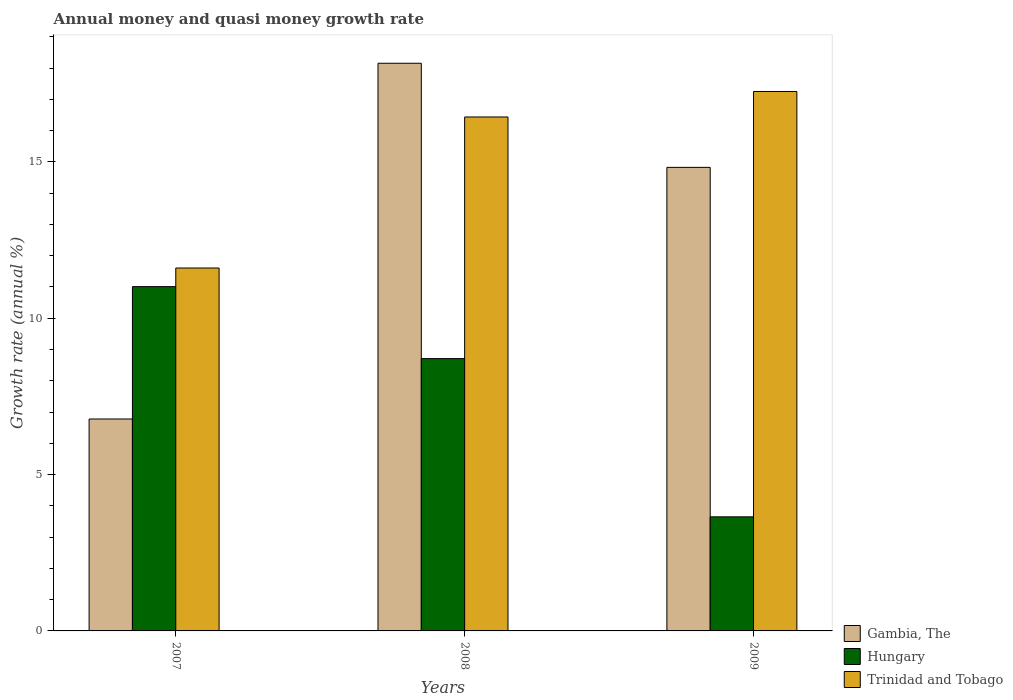How many different coloured bars are there?
Offer a very short reply. 3. Are the number of bars per tick equal to the number of legend labels?
Provide a succinct answer. Yes. How many bars are there on the 3rd tick from the right?
Keep it short and to the point. 3. In how many cases, is the number of bars for a given year not equal to the number of legend labels?
Provide a short and direct response. 0. What is the growth rate in Gambia, The in 2009?
Provide a succinct answer. 14.83. Across all years, what is the maximum growth rate in Gambia, The?
Offer a terse response. 18.16. Across all years, what is the minimum growth rate in Hungary?
Offer a very short reply. 3.65. In which year was the growth rate in Trinidad and Tobago minimum?
Provide a succinct answer. 2007. What is the total growth rate in Hungary in the graph?
Give a very brief answer. 23.37. What is the difference between the growth rate in Trinidad and Tobago in 2007 and that in 2009?
Keep it short and to the point. -5.65. What is the difference between the growth rate in Trinidad and Tobago in 2008 and the growth rate in Hungary in 2009?
Give a very brief answer. 12.79. What is the average growth rate in Trinidad and Tobago per year?
Keep it short and to the point. 15.1. In the year 2009, what is the difference between the growth rate in Trinidad and Tobago and growth rate in Gambia, The?
Provide a succinct answer. 2.43. What is the ratio of the growth rate in Trinidad and Tobago in 2007 to that in 2008?
Offer a terse response. 0.71. What is the difference between the highest and the second highest growth rate in Trinidad and Tobago?
Offer a terse response. 0.82. What is the difference between the highest and the lowest growth rate in Gambia, The?
Provide a succinct answer. 11.38. In how many years, is the growth rate in Trinidad and Tobago greater than the average growth rate in Trinidad and Tobago taken over all years?
Provide a short and direct response. 2. What does the 3rd bar from the left in 2008 represents?
Your answer should be very brief. Trinidad and Tobago. What does the 3rd bar from the right in 2009 represents?
Ensure brevity in your answer.  Gambia, The. Is it the case that in every year, the sum of the growth rate in Trinidad and Tobago and growth rate in Gambia, The is greater than the growth rate in Hungary?
Keep it short and to the point. Yes. Are all the bars in the graph horizontal?
Offer a very short reply. No. How many years are there in the graph?
Offer a very short reply. 3. What is the difference between two consecutive major ticks on the Y-axis?
Provide a succinct answer. 5. Are the values on the major ticks of Y-axis written in scientific E-notation?
Keep it short and to the point. No. Where does the legend appear in the graph?
Provide a short and direct response. Bottom right. How many legend labels are there?
Give a very brief answer. 3. What is the title of the graph?
Your answer should be compact. Annual money and quasi money growth rate. What is the label or title of the Y-axis?
Your response must be concise. Growth rate (annual %). What is the Growth rate (annual %) in Gambia, The in 2007?
Give a very brief answer. 6.78. What is the Growth rate (annual %) in Hungary in 2007?
Provide a short and direct response. 11.01. What is the Growth rate (annual %) in Trinidad and Tobago in 2007?
Ensure brevity in your answer.  11.61. What is the Growth rate (annual %) in Gambia, The in 2008?
Ensure brevity in your answer.  18.16. What is the Growth rate (annual %) in Hungary in 2008?
Provide a short and direct response. 8.71. What is the Growth rate (annual %) in Trinidad and Tobago in 2008?
Provide a succinct answer. 16.44. What is the Growth rate (annual %) in Gambia, The in 2009?
Offer a very short reply. 14.83. What is the Growth rate (annual %) of Hungary in 2009?
Your response must be concise. 3.65. What is the Growth rate (annual %) in Trinidad and Tobago in 2009?
Your answer should be very brief. 17.25. Across all years, what is the maximum Growth rate (annual %) of Gambia, The?
Provide a succinct answer. 18.16. Across all years, what is the maximum Growth rate (annual %) of Hungary?
Provide a short and direct response. 11.01. Across all years, what is the maximum Growth rate (annual %) in Trinidad and Tobago?
Provide a short and direct response. 17.25. Across all years, what is the minimum Growth rate (annual %) of Gambia, The?
Your response must be concise. 6.78. Across all years, what is the minimum Growth rate (annual %) of Hungary?
Your response must be concise. 3.65. Across all years, what is the minimum Growth rate (annual %) of Trinidad and Tobago?
Your answer should be compact. 11.61. What is the total Growth rate (annual %) of Gambia, The in the graph?
Your answer should be compact. 39.76. What is the total Growth rate (annual %) of Hungary in the graph?
Offer a terse response. 23.37. What is the total Growth rate (annual %) of Trinidad and Tobago in the graph?
Your response must be concise. 45.3. What is the difference between the Growth rate (annual %) of Gambia, The in 2007 and that in 2008?
Ensure brevity in your answer.  -11.38. What is the difference between the Growth rate (annual %) of Hungary in 2007 and that in 2008?
Offer a terse response. 2.3. What is the difference between the Growth rate (annual %) of Trinidad and Tobago in 2007 and that in 2008?
Provide a succinct answer. -4.83. What is the difference between the Growth rate (annual %) in Gambia, The in 2007 and that in 2009?
Offer a terse response. -8.05. What is the difference between the Growth rate (annual %) of Hungary in 2007 and that in 2009?
Ensure brevity in your answer.  7.36. What is the difference between the Growth rate (annual %) of Trinidad and Tobago in 2007 and that in 2009?
Provide a short and direct response. -5.65. What is the difference between the Growth rate (annual %) in Gambia, The in 2008 and that in 2009?
Ensure brevity in your answer.  3.33. What is the difference between the Growth rate (annual %) in Hungary in 2008 and that in 2009?
Make the answer very short. 5.06. What is the difference between the Growth rate (annual %) of Trinidad and Tobago in 2008 and that in 2009?
Ensure brevity in your answer.  -0.82. What is the difference between the Growth rate (annual %) in Gambia, The in 2007 and the Growth rate (annual %) in Hungary in 2008?
Offer a terse response. -1.93. What is the difference between the Growth rate (annual %) in Gambia, The in 2007 and the Growth rate (annual %) in Trinidad and Tobago in 2008?
Provide a succinct answer. -9.66. What is the difference between the Growth rate (annual %) in Hungary in 2007 and the Growth rate (annual %) in Trinidad and Tobago in 2008?
Give a very brief answer. -5.43. What is the difference between the Growth rate (annual %) of Gambia, The in 2007 and the Growth rate (annual %) of Hungary in 2009?
Your answer should be very brief. 3.13. What is the difference between the Growth rate (annual %) in Gambia, The in 2007 and the Growth rate (annual %) in Trinidad and Tobago in 2009?
Ensure brevity in your answer.  -10.48. What is the difference between the Growth rate (annual %) of Hungary in 2007 and the Growth rate (annual %) of Trinidad and Tobago in 2009?
Offer a terse response. -6.24. What is the difference between the Growth rate (annual %) of Gambia, The in 2008 and the Growth rate (annual %) of Hungary in 2009?
Provide a succinct answer. 14.51. What is the difference between the Growth rate (annual %) in Gambia, The in 2008 and the Growth rate (annual %) in Trinidad and Tobago in 2009?
Keep it short and to the point. 0.9. What is the difference between the Growth rate (annual %) of Hungary in 2008 and the Growth rate (annual %) of Trinidad and Tobago in 2009?
Offer a very short reply. -8.54. What is the average Growth rate (annual %) of Gambia, The per year?
Your answer should be very brief. 13.25. What is the average Growth rate (annual %) of Hungary per year?
Your response must be concise. 7.79. What is the average Growth rate (annual %) in Trinidad and Tobago per year?
Your response must be concise. 15.1. In the year 2007, what is the difference between the Growth rate (annual %) of Gambia, The and Growth rate (annual %) of Hungary?
Provide a succinct answer. -4.23. In the year 2007, what is the difference between the Growth rate (annual %) of Gambia, The and Growth rate (annual %) of Trinidad and Tobago?
Your response must be concise. -4.83. In the year 2007, what is the difference between the Growth rate (annual %) in Hungary and Growth rate (annual %) in Trinidad and Tobago?
Your response must be concise. -0.6. In the year 2008, what is the difference between the Growth rate (annual %) of Gambia, The and Growth rate (annual %) of Hungary?
Your answer should be very brief. 9.45. In the year 2008, what is the difference between the Growth rate (annual %) of Gambia, The and Growth rate (annual %) of Trinidad and Tobago?
Provide a succinct answer. 1.72. In the year 2008, what is the difference between the Growth rate (annual %) of Hungary and Growth rate (annual %) of Trinidad and Tobago?
Your response must be concise. -7.73. In the year 2009, what is the difference between the Growth rate (annual %) in Gambia, The and Growth rate (annual %) in Hungary?
Provide a short and direct response. 11.18. In the year 2009, what is the difference between the Growth rate (annual %) of Gambia, The and Growth rate (annual %) of Trinidad and Tobago?
Your answer should be very brief. -2.43. In the year 2009, what is the difference between the Growth rate (annual %) in Hungary and Growth rate (annual %) in Trinidad and Tobago?
Ensure brevity in your answer.  -13.61. What is the ratio of the Growth rate (annual %) in Gambia, The in 2007 to that in 2008?
Your response must be concise. 0.37. What is the ratio of the Growth rate (annual %) in Hungary in 2007 to that in 2008?
Offer a terse response. 1.26. What is the ratio of the Growth rate (annual %) of Trinidad and Tobago in 2007 to that in 2008?
Provide a succinct answer. 0.71. What is the ratio of the Growth rate (annual %) of Gambia, The in 2007 to that in 2009?
Provide a short and direct response. 0.46. What is the ratio of the Growth rate (annual %) in Hungary in 2007 to that in 2009?
Offer a terse response. 3.02. What is the ratio of the Growth rate (annual %) in Trinidad and Tobago in 2007 to that in 2009?
Your answer should be very brief. 0.67. What is the ratio of the Growth rate (annual %) of Gambia, The in 2008 to that in 2009?
Provide a succinct answer. 1.22. What is the ratio of the Growth rate (annual %) of Hungary in 2008 to that in 2009?
Give a very brief answer. 2.39. What is the ratio of the Growth rate (annual %) in Trinidad and Tobago in 2008 to that in 2009?
Ensure brevity in your answer.  0.95. What is the difference between the highest and the second highest Growth rate (annual %) in Gambia, The?
Provide a short and direct response. 3.33. What is the difference between the highest and the second highest Growth rate (annual %) of Hungary?
Provide a succinct answer. 2.3. What is the difference between the highest and the second highest Growth rate (annual %) in Trinidad and Tobago?
Your response must be concise. 0.82. What is the difference between the highest and the lowest Growth rate (annual %) in Gambia, The?
Your response must be concise. 11.38. What is the difference between the highest and the lowest Growth rate (annual %) in Hungary?
Your answer should be compact. 7.36. What is the difference between the highest and the lowest Growth rate (annual %) of Trinidad and Tobago?
Your answer should be compact. 5.65. 